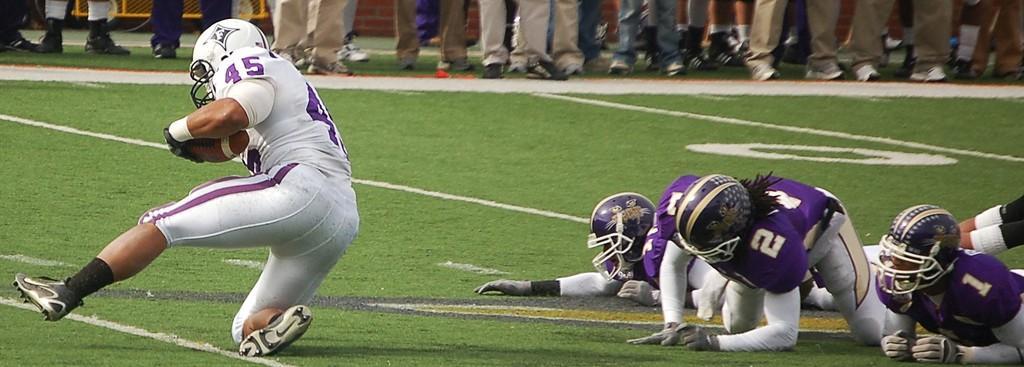Describe this image in one or two sentences. In the left side a man is running by holding a ball in his hand, he wore a white color dress. In the right side 3 persons are laying on the ground, these persons wore brinjal color dresses 